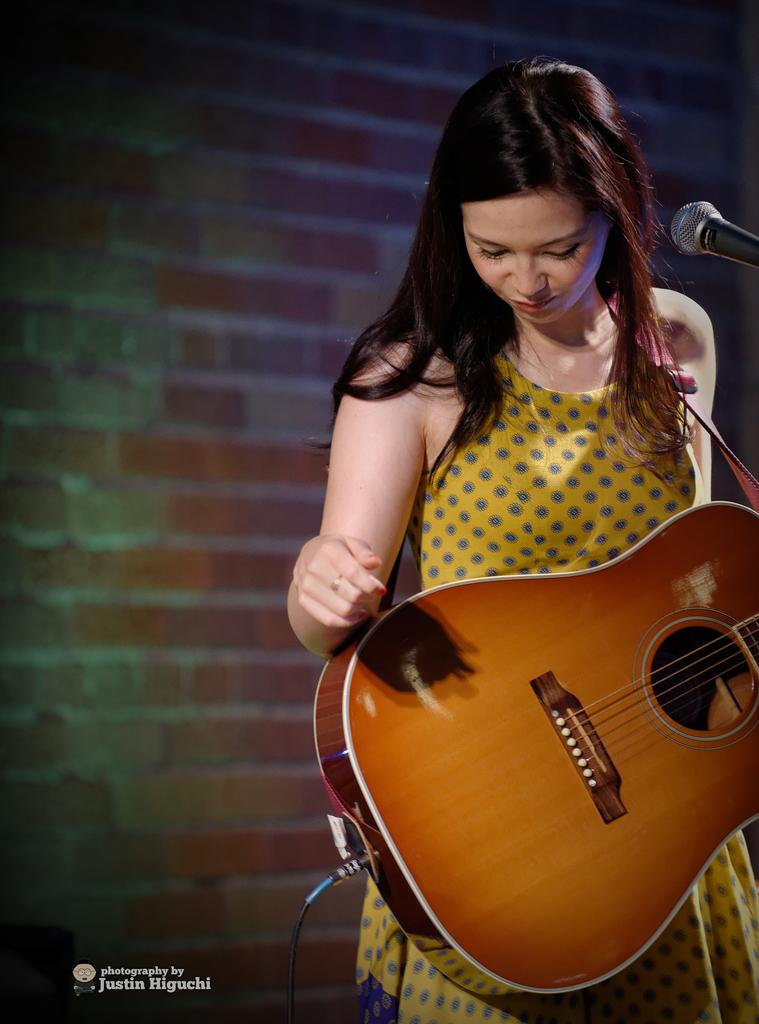Who is the main subject in the image? There is a woman in the image. What is the woman doing in the image? The woman is standing and holding a musical instrument in her hand. What object is in front of the woman? There is a microphone in front of her. What can be seen in the background of the image? There is a wall with red-colored bricks in the background. How many trucks are parked behind the woman in the image? There are no trucks visible in the image; it only shows a woman standing with a musical instrument and a microphone in front of her. 